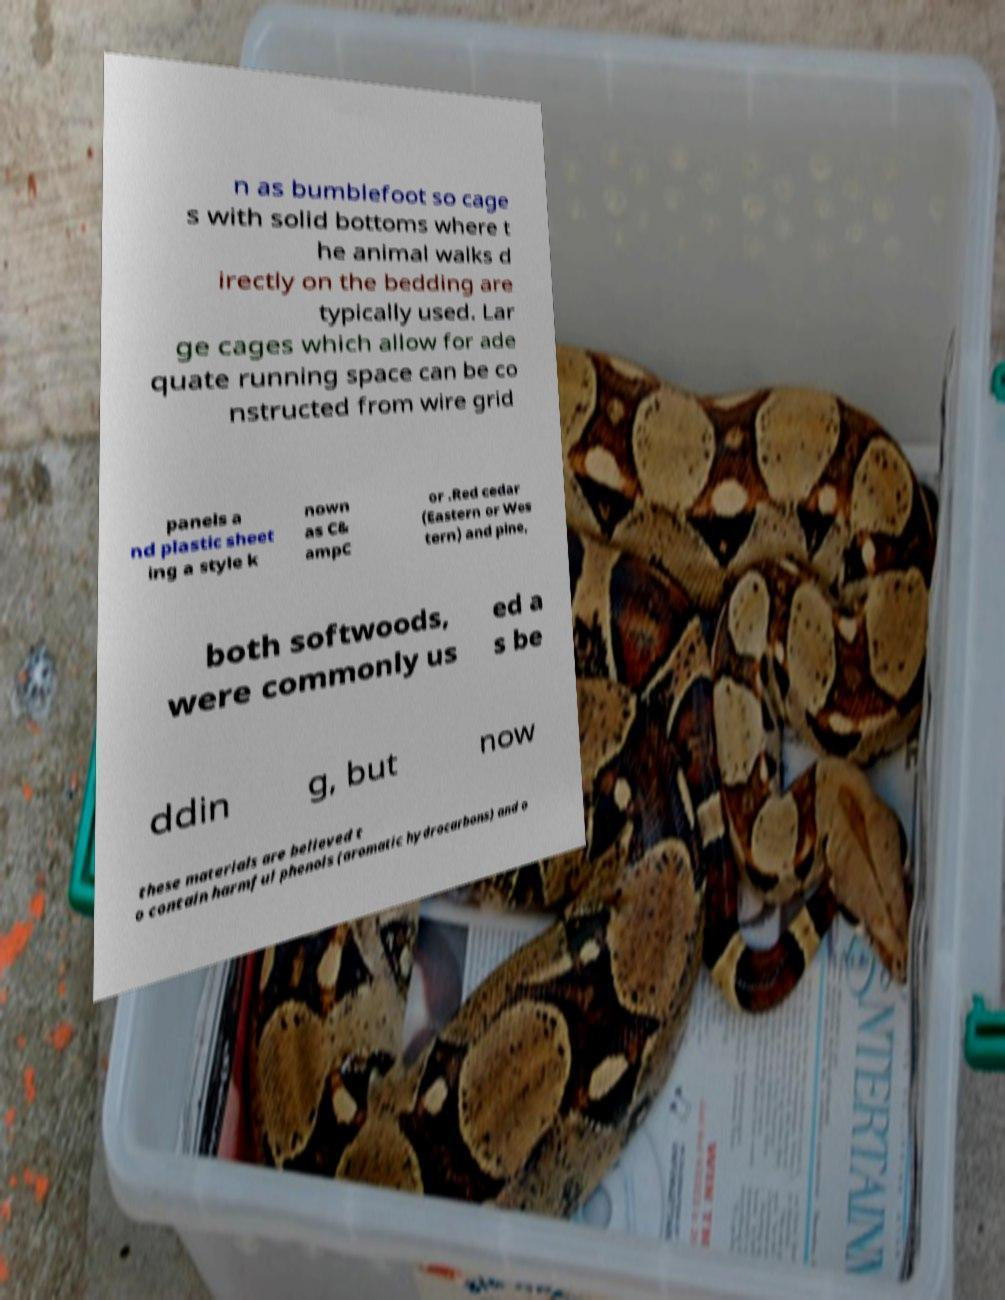Please read and relay the text visible in this image. What does it say? n as bumblefoot so cage s with solid bottoms where t he animal walks d irectly on the bedding are typically used. Lar ge cages which allow for ade quate running space can be co nstructed from wire grid panels a nd plastic sheet ing a style k nown as C& ampC or .Red cedar (Eastern or Wes tern) and pine, both softwoods, were commonly us ed a s be ddin g, but now these materials are believed t o contain harmful phenols (aromatic hydrocarbons) and o 